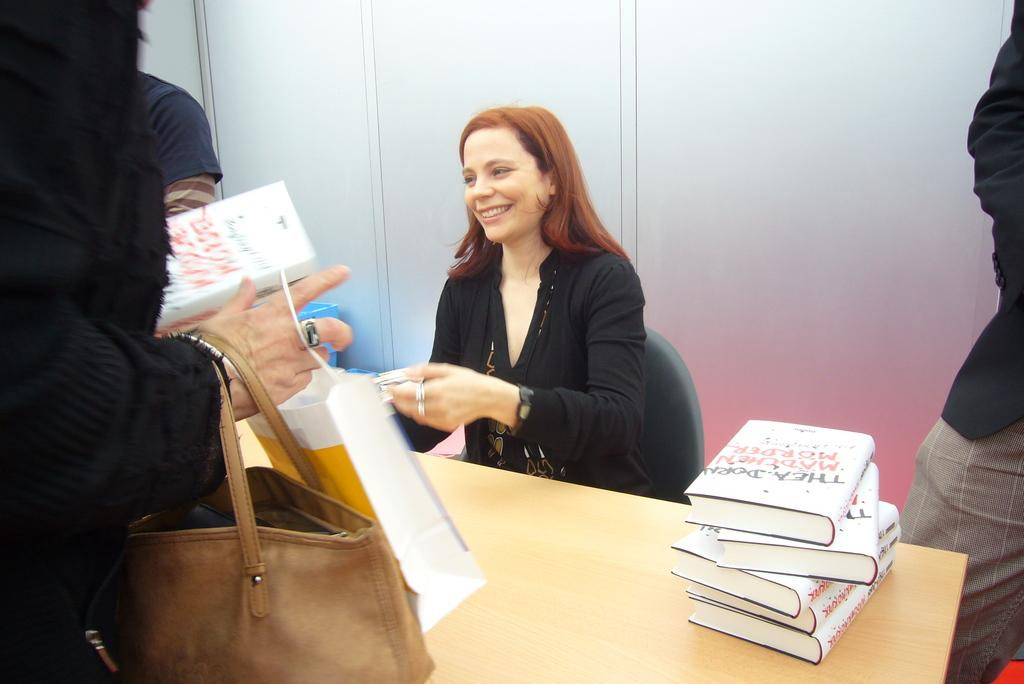How many people are present in the image? There are four people in the image. What is the position of one of the ladies in the image? One lady is sitting. What are the other three people doing in the image? The other three people are standing. Where are they standing in relation to the table? They are standing around a table. What objects can be seen on the table? There are books on the table. How many passengers are visible in the image? There is no reference to passengers in the image, as it features people standing and sitting around a table with books. 